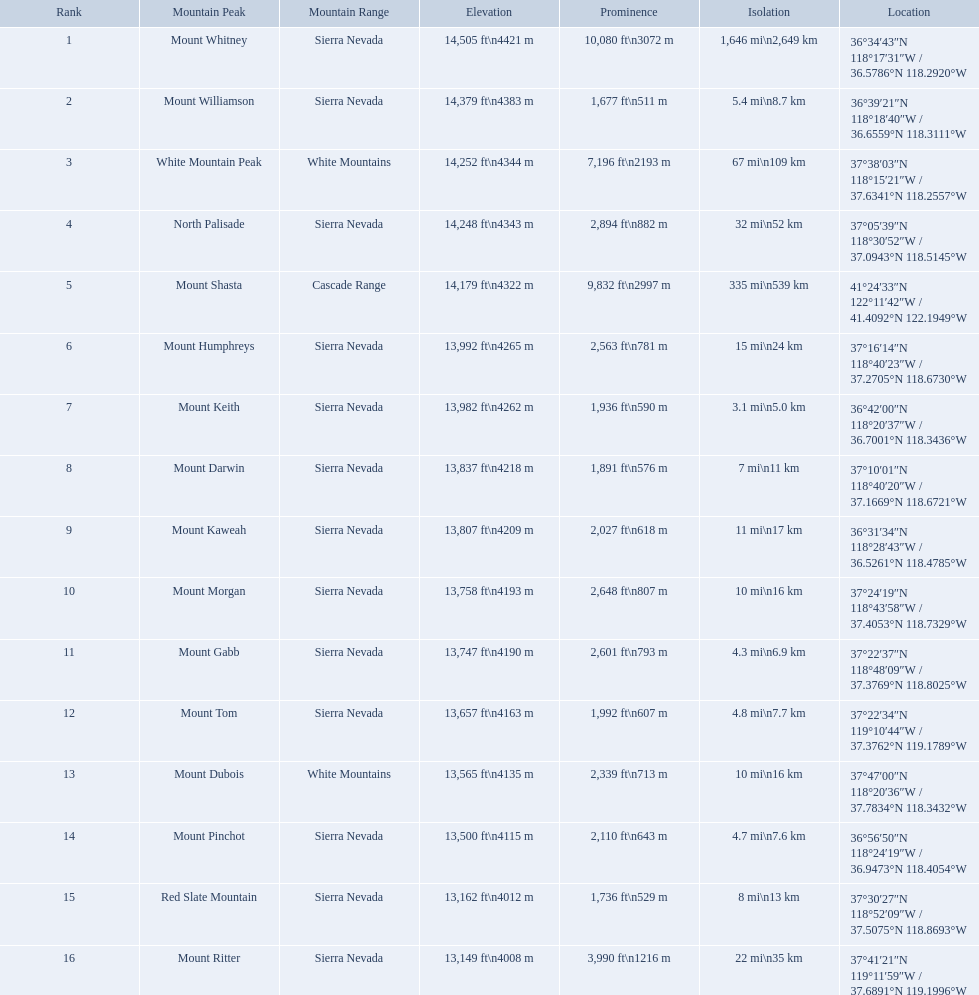Which mountain peak is in the white mountains range? White Mountain Peak. Which mountain is in the sierra nevada range? Mount Whitney. Which mountain is the only one in the cascade range? Mount Shasta. What are the prominence lengths higher than 10,000 feet? 10,080 ft\n3072 m. What mountain peak has a prominence of 10,080 feet? Mount Whitney. What are the listed elevations? 14,505 ft\n4421 m, 14,379 ft\n4383 m, 14,252 ft\n4344 m, 14,248 ft\n4343 m, 14,179 ft\n4322 m, 13,992 ft\n4265 m, 13,982 ft\n4262 m, 13,837 ft\n4218 m, 13,807 ft\n4209 m, 13,758 ft\n4193 m, 13,747 ft\n4190 m, 13,657 ft\n4163 m, 13,565 ft\n4135 m, 13,500 ft\n4115 m, 13,162 ft\n4012 m, 13,149 ft\n4008 m. Which of those is 13,149 ft or below? 13,149 ft\n4008 m. To what mountain peak does that value correspond? Mount Ritter. What are the heights of the peaks? 14,505 ft\n4421 m, 14,379 ft\n4383 m, 14,252 ft\n4344 m, 14,248 ft\n4343 m, 14,179 ft\n4322 m, 13,992 ft\n4265 m, 13,982 ft\n4262 m, 13,837 ft\n4218 m, 13,807 ft\n4209 m, 13,758 ft\n4193 m, 13,747 ft\n4190 m, 13,657 ft\n4163 m, 13,565 ft\n4135 m, 13,500 ft\n4115 m, 13,162 ft\n4012 m, 13,149 ft\n4008 m. Which of these heights is tallest? 14,505 ft\n4421 m. What peak is 14,505 feet? Mount Whitney. Which are the highest mountain peaks in california? Mount Whitney, Mount Williamson, White Mountain Peak, North Palisade, Mount Shasta, Mount Humphreys, Mount Keith, Mount Darwin, Mount Kaweah, Mount Morgan, Mount Gabb, Mount Tom, Mount Dubois, Mount Pinchot, Red Slate Mountain, Mount Ritter. Of those, which are not in the sierra nevada range? White Mountain Peak, Mount Shasta, Mount Dubois. Of the mountains not in the sierra nevada range, which is the only mountain in the cascades? Mount Shasta. What are the peak points of mountains? Mount Whitney, Mount Williamson, White Mountain Peak, North Palisade, Mount Shasta, Mount Humphreys, Mount Keith, Mount Darwin, Mount Kaweah, Mount Morgan, Mount Gabb, Mount Tom, Mount Dubois, Mount Pinchot, Red Slate Mountain, Mount Ritter. From these, which is in the cascade range? Mount Shasta. What mountain summit is mentioned for the sierra nevada mountain range? Mount Whitney. What mountain summit has a height of 14,379ft? Mount Williamson. Which mountain is mentioned for the cascade range? Mount Shasta. Which summit is located in the white mountains range? White Mountain Peak. Which mountain is situated in the sierra nevada range? Mount Whitney. Which mountain is the sole one in the cascade range? Mount Shasta. Parse the full table. {'header': ['Rank', 'Mountain Peak', 'Mountain Range', 'Elevation', 'Prominence', 'Isolation', 'Location'], 'rows': [['1', 'Mount Whitney', 'Sierra Nevada', '14,505\xa0ft\\n4421\xa0m', '10,080\xa0ft\\n3072\xa0m', '1,646\xa0mi\\n2,649\xa0km', '36°34′43″N 118°17′31″W\ufeff / \ufeff36.5786°N 118.2920°W'], ['2', 'Mount Williamson', 'Sierra Nevada', '14,379\xa0ft\\n4383\xa0m', '1,677\xa0ft\\n511\xa0m', '5.4\xa0mi\\n8.7\xa0km', '36°39′21″N 118°18′40″W\ufeff / \ufeff36.6559°N 118.3111°W'], ['3', 'White Mountain Peak', 'White Mountains', '14,252\xa0ft\\n4344\xa0m', '7,196\xa0ft\\n2193\xa0m', '67\xa0mi\\n109\xa0km', '37°38′03″N 118°15′21″W\ufeff / \ufeff37.6341°N 118.2557°W'], ['4', 'North Palisade', 'Sierra Nevada', '14,248\xa0ft\\n4343\xa0m', '2,894\xa0ft\\n882\xa0m', '32\xa0mi\\n52\xa0km', '37°05′39″N 118°30′52″W\ufeff / \ufeff37.0943°N 118.5145°W'], ['5', 'Mount Shasta', 'Cascade Range', '14,179\xa0ft\\n4322\xa0m', '9,832\xa0ft\\n2997\xa0m', '335\xa0mi\\n539\xa0km', '41°24′33″N 122°11′42″W\ufeff / \ufeff41.4092°N 122.1949°W'], ['6', 'Mount Humphreys', 'Sierra Nevada', '13,992\xa0ft\\n4265\xa0m', '2,563\xa0ft\\n781\xa0m', '15\xa0mi\\n24\xa0km', '37°16′14″N 118°40′23″W\ufeff / \ufeff37.2705°N 118.6730°W'], ['7', 'Mount Keith', 'Sierra Nevada', '13,982\xa0ft\\n4262\xa0m', '1,936\xa0ft\\n590\xa0m', '3.1\xa0mi\\n5.0\xa0km', '36°42′00″N 118°20′37″W\ufeff / \ufeff36.7001°N 118.3436°W'], ['8', 'Mount Darwin', 'Sierra Nevada', '13,837\xa0ft\\n4218\xa0m', '1,891\xa0ft\\n576\xa0m', '7\xa0mi\\n11\xa0km', '37°10′01″N 118°40′20″W\ufeff / \ufeff37.1669°N 118.6721°W'], ['9', 'Mount Kaweah', 'Sierra Nevada', '13,807\xa0ft\\n4209\xa0m', '2,027\xa0ft\\n618\xa0m', '11\xa0mi\\n17\xa0km', '36°31′34″N 118°28′43″W\ufeff / \ufeff36.5261°N 118.4785°W'], ['10', 'Mount Morgan', 'Sierra Nevada', '13,758\xa0ft\\n4193\xa0m', '2,648\xa0ft\\n807\xa0m', '10\xa0mi\\n16\xa0km', '37°24′19″N 118°43′58″W\ufeff / \ufeff37.4053°N 118.7329°W'], ['11', 'Mount Gabb', 'Sierra Nevada', '13,747\xa0ft\\n4190\xa0m', '2,601\xa0ft\\n793\xa0m', '4.3\xa0mi\\n6.9\xa0km', '37°22′37″N 118°48′09″W\ufeff / \ufeff37.3769°N 118.8025°W'], ['12', 'Mount Tom', 'Sierra Nevada', '13,657\xa0ft\\n4163\xa0m', '1,992\xa0ft\\n607\xa0m', '4.8\xa0mi\\n7.7\xa0km', '37°22′34″N 119°10′44″W\ufeff / \ufeff37.3762°N 119.1789°W'], ['13', 'Mount Dubois', 'White Mountains', '13,565\xa0ft\\n4135\xa0m', '2,339\xa0ft\\n713\xa0m', '10\xa0mi\\n16\xa0km', '37°47′00″N 118°20′36″W\ufeff / \ufeff37.7834°N 118.3432°W'], ['14', 'Mount Pinchot', 'Sierra Nevada', '13,500\xa0ft\\n4115\xa0m', '2,110\xa0ft\\n643\xa0m', '4.7\xa0mi\\n7.6\xa0km', '36°56′50″N 118°24′19″W\ufeff / \ufeff36.9473°N 118.4054°W'], ['15', 'Red Slate Mountain', 'Sierra Nevada', '13,162\xa0ft\\n4012\xa0m', '1,736\xa0ft\\n529\xa0m', '8\xa0mi\\n13\xa0km', '37°30′27″N 118°52′09″W\ufeff / \ufeff37.5075°N 118.8693°W'], ['16', 'Mount Ritter', 'Sierra Nevada', '13,149\xa0ft\\n4008\xa0m', '3,990\xa0ft\\n1216\xa0m', '22\xa0mi\\n35\xa0km', '37°41′21″N 119°11′59″W\ufeff / \ufeff37.6891°N 119.1996°W']]} Which mountain apexes hold a prominence beyond 9,000 ft? Mount Whitney, Mount Shasta. From those, which one boasts the maximum prominence? Mount Whitney. What are the elevations of california's mountain peaks? 14,505 ft\n4421 m, 14,379 ft\n4383 m, 14,252 ft\n4344 m, 14,248 ft\n4343 m, 14,179 ft\n4322 m, 13,992 ft\n4265 m, 13,982 ft\n4262 m, 13,837 ft\n4218 m, 13,807 ft\n4209 m, 13,758 ft\n4193 m, 13,747 ft\n4190 m, 13,657 ft\n4163 m, 13,565 ft\n4135 m, 13,500 ft\n4115 m, 13,162 ft\n4012 m, 13,149 ft\n4008 m. What height is 13,149 ft or below? 13,149 ft\n4008 m. Which mountain summit is at this height? Mount Ritter. What are the mountain tops? Mount Whitney, Mount Williamson, White Mountain Peak, North Palisade, Mount Shasta, Mount Humphreys, Mount Keith, Mount Darwin, Mount Kaweah, Mount Morgan, Mount Gabb, Mount Tom, Mount Dubois, Mount Pinchot, Red Slate Mountain, Mount Ritter. Among them, which one has a prominence greater than 10,000 ft? Mount Whitney. What mountain apex is recorded for the sierra nevada mountain range? Mount Whitney. What mountain apex has an altitude of 14,379ft? Mount Williamson. Which mountain is recorded for the cascade range? Mount Shasta. What are the altitudes of the mountain peaks in california? 14,505 ft\n4421 m, 14,379 ft\n4383 m, 14,252 ft\n4344 m, 14,248 ft\n4343 m, 14,179 ft\n4322 m, 13,992 ft\n4265 m, 13,982 ft\n4262 m, 13,837 ft\n4218 m, 13,807 ft\n4209 m, 13,758 ft\n4193 m, 13,747 ft\n4190 m, 13,657 ft\n4163 m, 13,565 ft\n4135 m, 13,500 ft\n4115 m, 13,162 ft\n4012 m, 13,149 ft\n4008 m. What level is 13,149 ft or lower? 13,149 ft\n4008 m. What mountain pinnacle is at this altitude? Mount Ritter. What are the specified altitudes? 14,505 ft\n4421 m, 14,379 ft\n4383 m, 14,252 ft\n4344 m, 14,248 ft\n4343 m, 14,179 ft\n4322 m, 13,992 ft\n4265 m, 13,982 ft\n4262 m, 13,837 ft\n4218 m, 13,807 ft\n4209 m, 13,758 ft\n4193 m, 13,747 ft\n4190 m, 13,657 ft\n4163 m, 13,565 ft\n4135 m, 13,500 ft\n4115 m, 13,162 ft\n4012 m, 13,149 ft\n4008 m. Which among them is 13,149 ft or beneath? 13,149 ft\n4008 m. To which mountain pinnacle does this number pertain? Mount Ritter. What are all the mountain pinnacles? Mount Whitney, Mount Williamson, White Mountain Peak, North Palisade, Mount Shasta, Mount Humphreys, Mount Keith, Mount Darwin, Mount Kaweah, Mount Morgan, Mount Gabb, Mount Tom, Mount Dubois, Mount Pinchot, Red Slate Mountain, Mount Ritter. In what series are they? Sierra Nevada, Sierra Nevada, White Mountains, Sierra Nevada, Cascade Range, Sierra Nevada, Sierra Nevada, Sierra Nevada, Sierra Nevada, Sierra Nevada, Sierra Nevada, Sierra Nevada, White Mountains, Sierra Nevada, Sierra Nevada, Sierra Nevada. Which pinnacle is in the cascade range? Mount Shasta. What are the prominence measures above 10,000 feet? 10,080 ft\n3072 m. What mountain apex has a prominence totaling 10,080 feet? Mount Whitney. Which mountain summits possess a prominence exceeding 9,000 ft? Mount Whitney, Mount Shasta. Among them, which one has the greatest prominence? Mount Whitney. Which peak can be found within the white mountains range? White Mountain Peak. Which mountain belongs to the sierra nevada range? Mount Whitney. Which mountain is the sole one in the cascade range? Mount Shasta. In the white mountains range, which mountain peak is present? White Mountain Peak. In the sierra nevada range, which mountain is located? Mount Whitney. In the cascade range, which mountain is the only one? Mount Shasta. What are the elevations of mountain peaks in california? 14,505 ft\n4421 m, 14,379 ft\n4383 m, 14,252 ft\n4344 m, 14,248 ft\n4343 m, 14,179 ft\n4322 m, 13,992 ft\n4265 m, 13,982 ft\n4262 m, 13,837 ft\n4218 m, 13,807 ft\n4209 m, 13,758 ft\n4193 m, 13,747 ft\n4190 m, 13,657 ft\n4163 m, 13,565 ft\n4135 m, 13,500 ft\n4115 m, 13,162 ft\n4012 m, 13,149 ft\n4008 m. Which peak has a height of 13,149 feet or lower? 13,149 ft\n4008 m. Can you name the mountain with this elevation? Mount Ritter. What are the elevations of the mountain peaks? 14,505 ft\n4421 m, 14,379 ft\n4383 m, 14,252 ft\n4344 m, 14,248 ft\n4343 m, 14,179 ft\n4322 m, 13,992 ft\n4265 m, 13,982 ft\n4262 m, 13,837 ft\n4218 m, 13,807 ft\n4209 m, 13,758 ft\n4193 m, 13,747 ft\n4190 m, 13,657 ft\n4163 m, 13,565 ft\n4135 m, 13,500 ft\n4115 m, 13,162 ft\n4012 m, 13,149 ft\n4008 m. Which peak has the highest elevation? 14,505 ft\n4421 m. Which peak stands at 14,505 feet? Mount Whitney. 